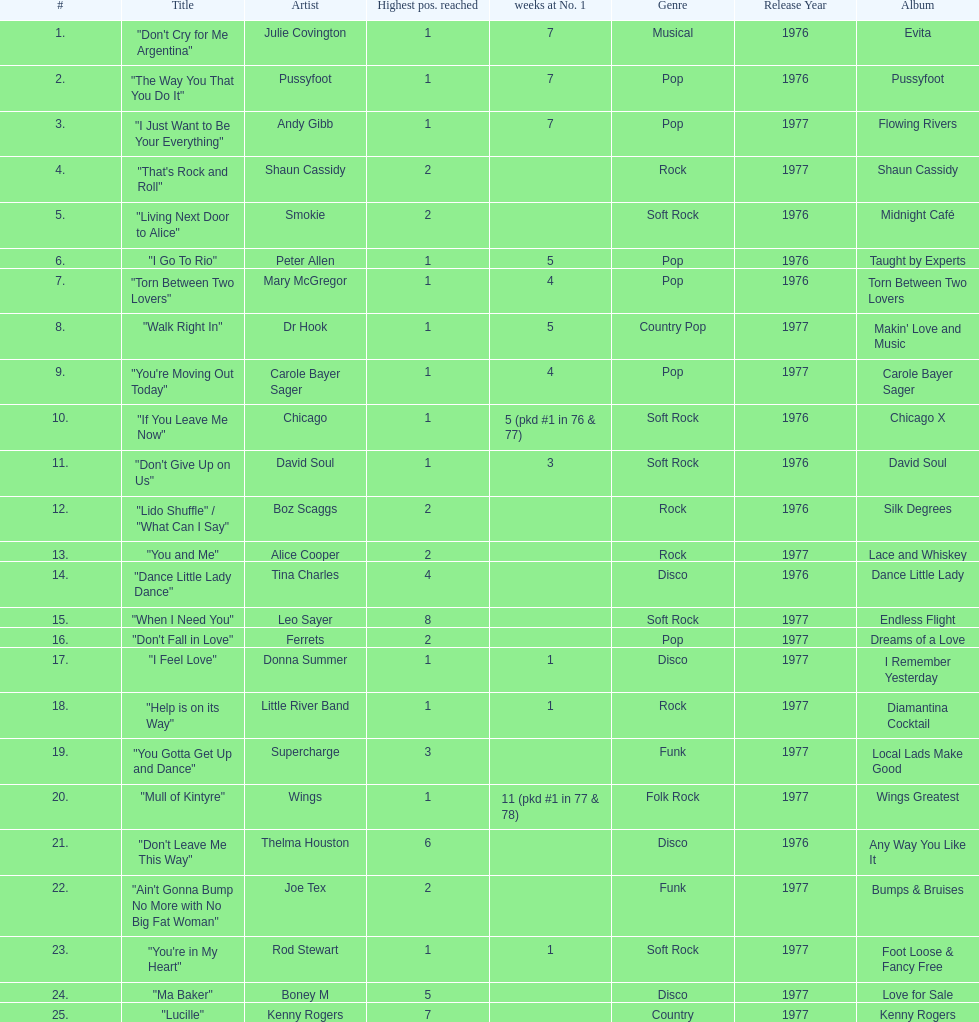Which song stayed at no.1 for the most amount of weeks. "Mull of Kintyre". 